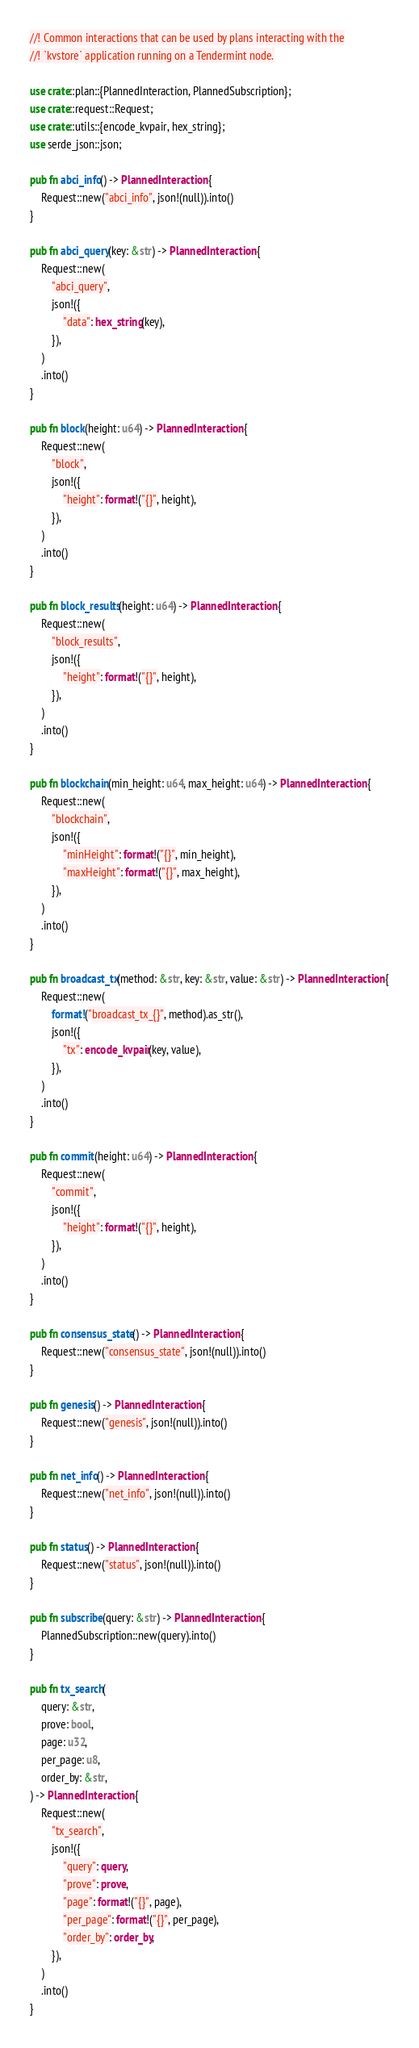<code> <loc_0><loc_0><loc_500><loc_500><_Rust_>//! Common interactions that can be used by plans interacting with the
//! `kvstore` application running on a Tendermint node.

use crate::plan::{PlannedInteraction, PlannedSubscription};
use crate::request::Request;
use crate::utils::{encode_kvpair, hex_string};
use serde_json::json;

pub fn abci_info() -> PlannedInteraction {
    Request::new("abci_info", json!(null)).into()
}

pub fn abci_query(key: &str) -> PlannedInteraction {
    Request::new(
        "abci_query",
        json!({
            "data": hex_string(key),
        }),
    )
    .into()
}

pub fn block(height: u64) -> PlannedInteraction {
    Request::new(
        "block",
        json!({
            "height": format!("{}", height),
        }),
    )
    .into()
}

pub fn block_results(height: u64) -> PlannedInteraction {
    Request::new(
        "block_results",
        json!({
            "height": format!("{}", height),
        }),
    )
    .into()
}

pub fn blockchain(min_height: u64, max_height: u64) -> PlannedInteraction {
    Request::new(
        "blockchain",
        json!({
            "minHeight": format!("{}", min_height),
            "maxHeight": format!("{}", max_height),
        }),
    )
    .into()
}

pub fn broadcast_tx(method: &str, key: &str, value: &str) -> PlannedInteraction {
    Request::new(
        format!("broadcast_tx_{}", method).as_str(),
        json!({
            "tx": encode_kvpair(key, value),
        }),
    )
    .into()
}

pub fn commit(height: u64) -> PlannedInteraction {
    Request::new(
        "commit",
        json!({
            "height": format!("{}", height),
        }),
    )
    .into()
}

pub fn consensus_state() -> PlannedInteraction {
    Request::new("consensus_state", json!(null)).into()
}

pub fn genesis() -> PlannedInteraction {
    Request::new("genesis", json!(null)).into()
}

pub fn net_info() -> PlannedInteraction {
    Request::new("net_info", json!(null)).into()
}

pub fn status() -> PlannedInteraction {
    Request::new("status", json!(null)).into()
}

pub fn subscribe(query: &str) -> PlannedInteraction {
    PlannedSubscription::new(query).into()
}

pub fn tx_search(
    query: &str,
    prove: bool,
    page: u32,
    per_page: u8,
    order_by: &str,
) -> PlannedInteraction {
    Request::new(
        "tx_search",
        json!({
            "query": query,
            "prove": prove,
            "page": format!("{}", page),
            "per_page": format!("{}", per_page),
            "order_by": order_by,
        }),
    )
    .into()
}
</code> 